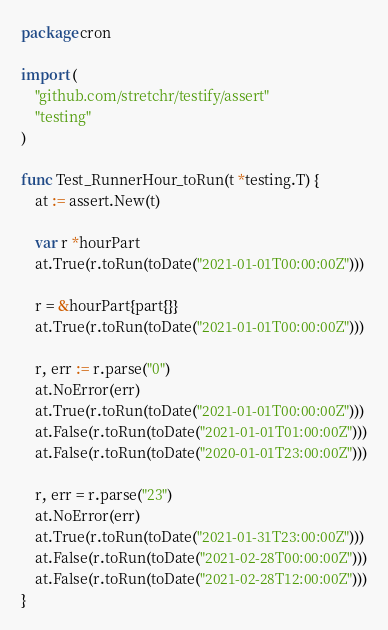<code> <loc_0><loc_0><loc_500><loc_500><_Go_>package cron

import (
	"github.com/stretchr/testify/assert"
	"testing"
)

func Test_RunnerHour_toRun(t *testing.T) {
	at := assert.New(t)

	var r *hourPart
	at.True(r.toRun(toDate("2021-01-01T00:00:00Z")))

	r = &hourPart{part{}}
	at.True(r.toRun(toDate("2021-01-01T00:00:00Z")))

	r, err := r.parse("0")
	at.NoError(err)
	at.True(r.toRun(toDate("2021-01-01T00:00:00Z")))
	at.False(r.toRun(toDate("2021-01-01T01:00:00Z")))
	at.False(r.toRun(toDate("2020-01-01T23:00:00Z")))

	r, err = r.parse("23")
	at.NoError(err)
	at.True(r.toRun(toDate("2021-01-31T23:00:00Z")))
	at.False(r.toRun(toDate("2021-02-28T00:00:00Z")))
	at.False(r.toRun(toDate("2021-02-28T12:00:00Z")))
}
</code> 